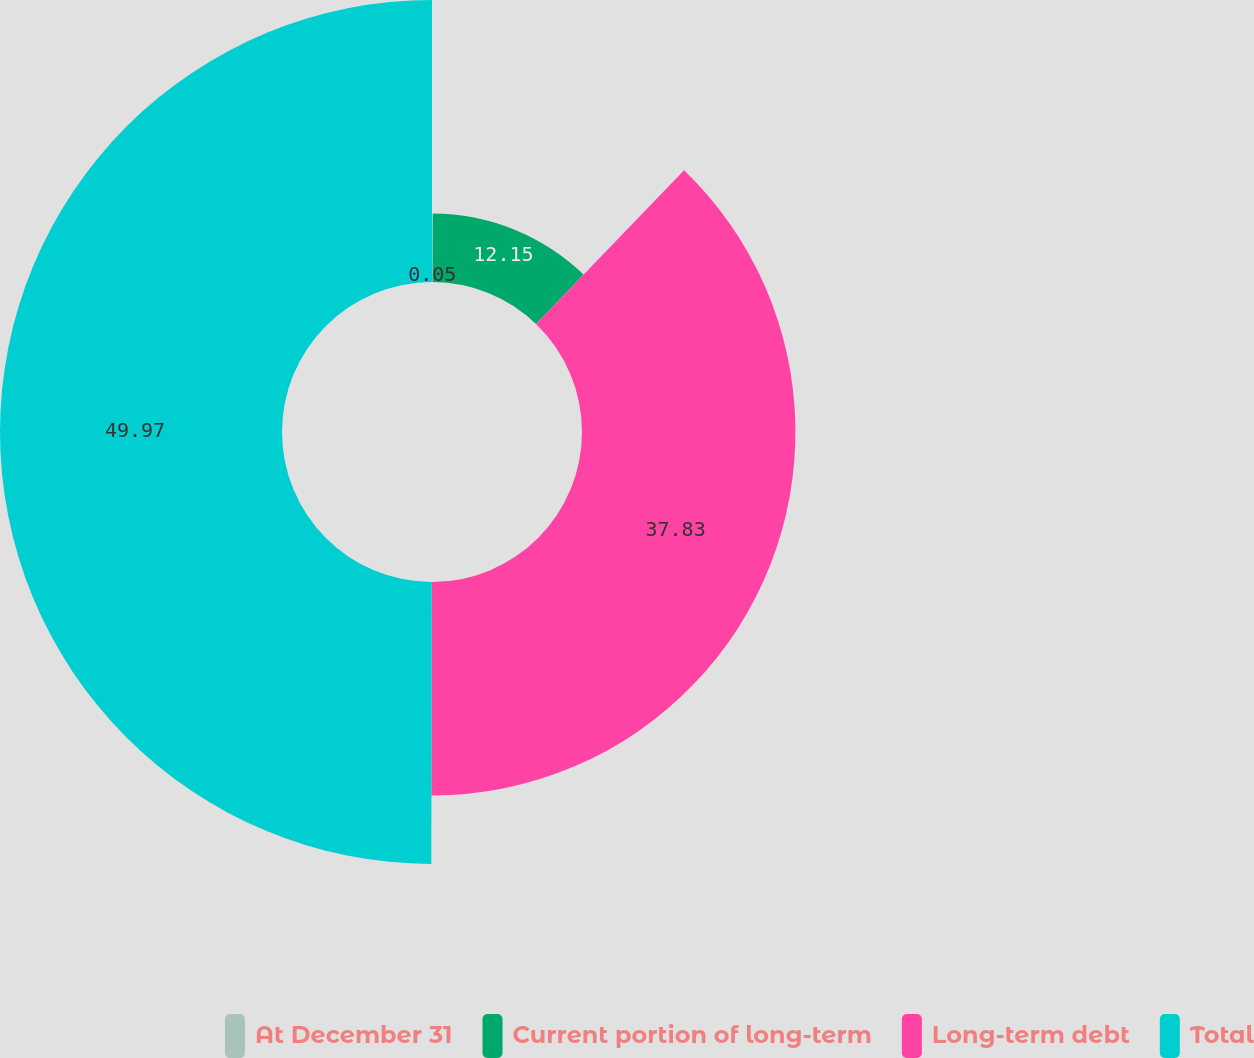Convert chart to OTSL. <chart><loc_0><loc_0><loc_500><loc_500><pie_chart><fcel>At December 31<fcel>Current portion of long-term<fcel>Long-term debt<fcel>Total<nl><fcel>0.05%<fcel>12.15%<fcel>37.83%<fcel>49.98%<nl></chart> 